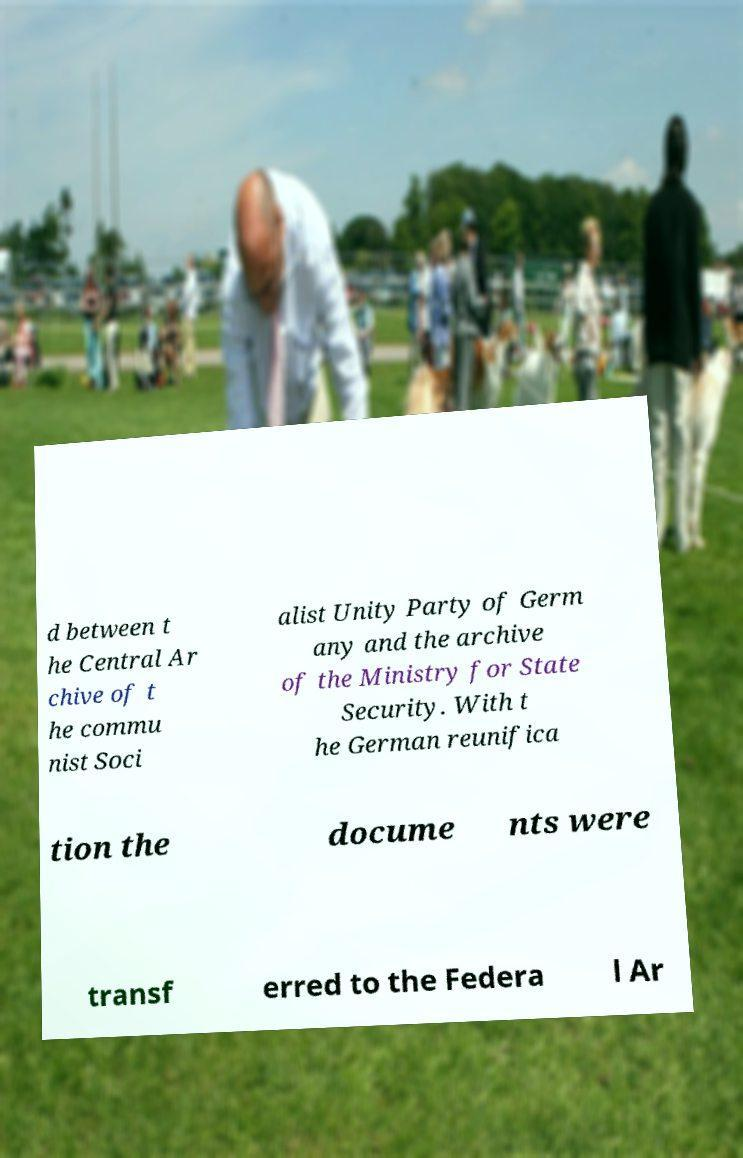Please identify and transcribe the text found in this image. d between t he Central Ar chive of t he commu nist Soci alist Unity Party of Germ any and the archive of the Ministry for State Security. With t he German reunifica tion the docume nts were transf erred to the Federa l Ar 